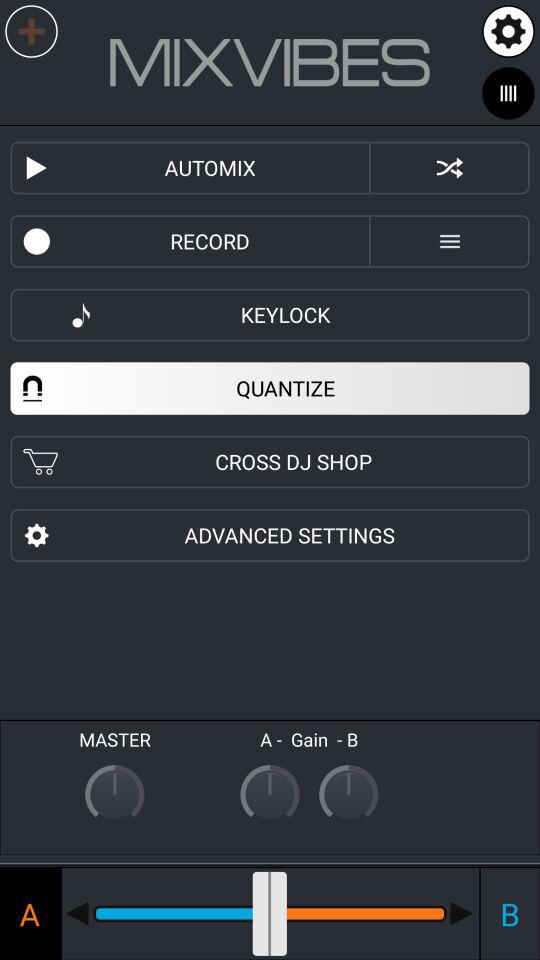What is the name of the application? The name of the application is "MIXVIBES". 